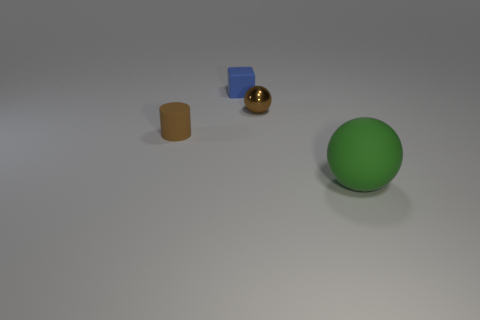Considering their sizes, how do you think these objects compare in weight? Based on their size and apparent materials, the large green ball might be the lightest if it's hollow, the plastic cylinder would be heavier, and the metallic cube and sphere are likely to be heavier still, with the cube potentially being the heaviest due to size and material density. 